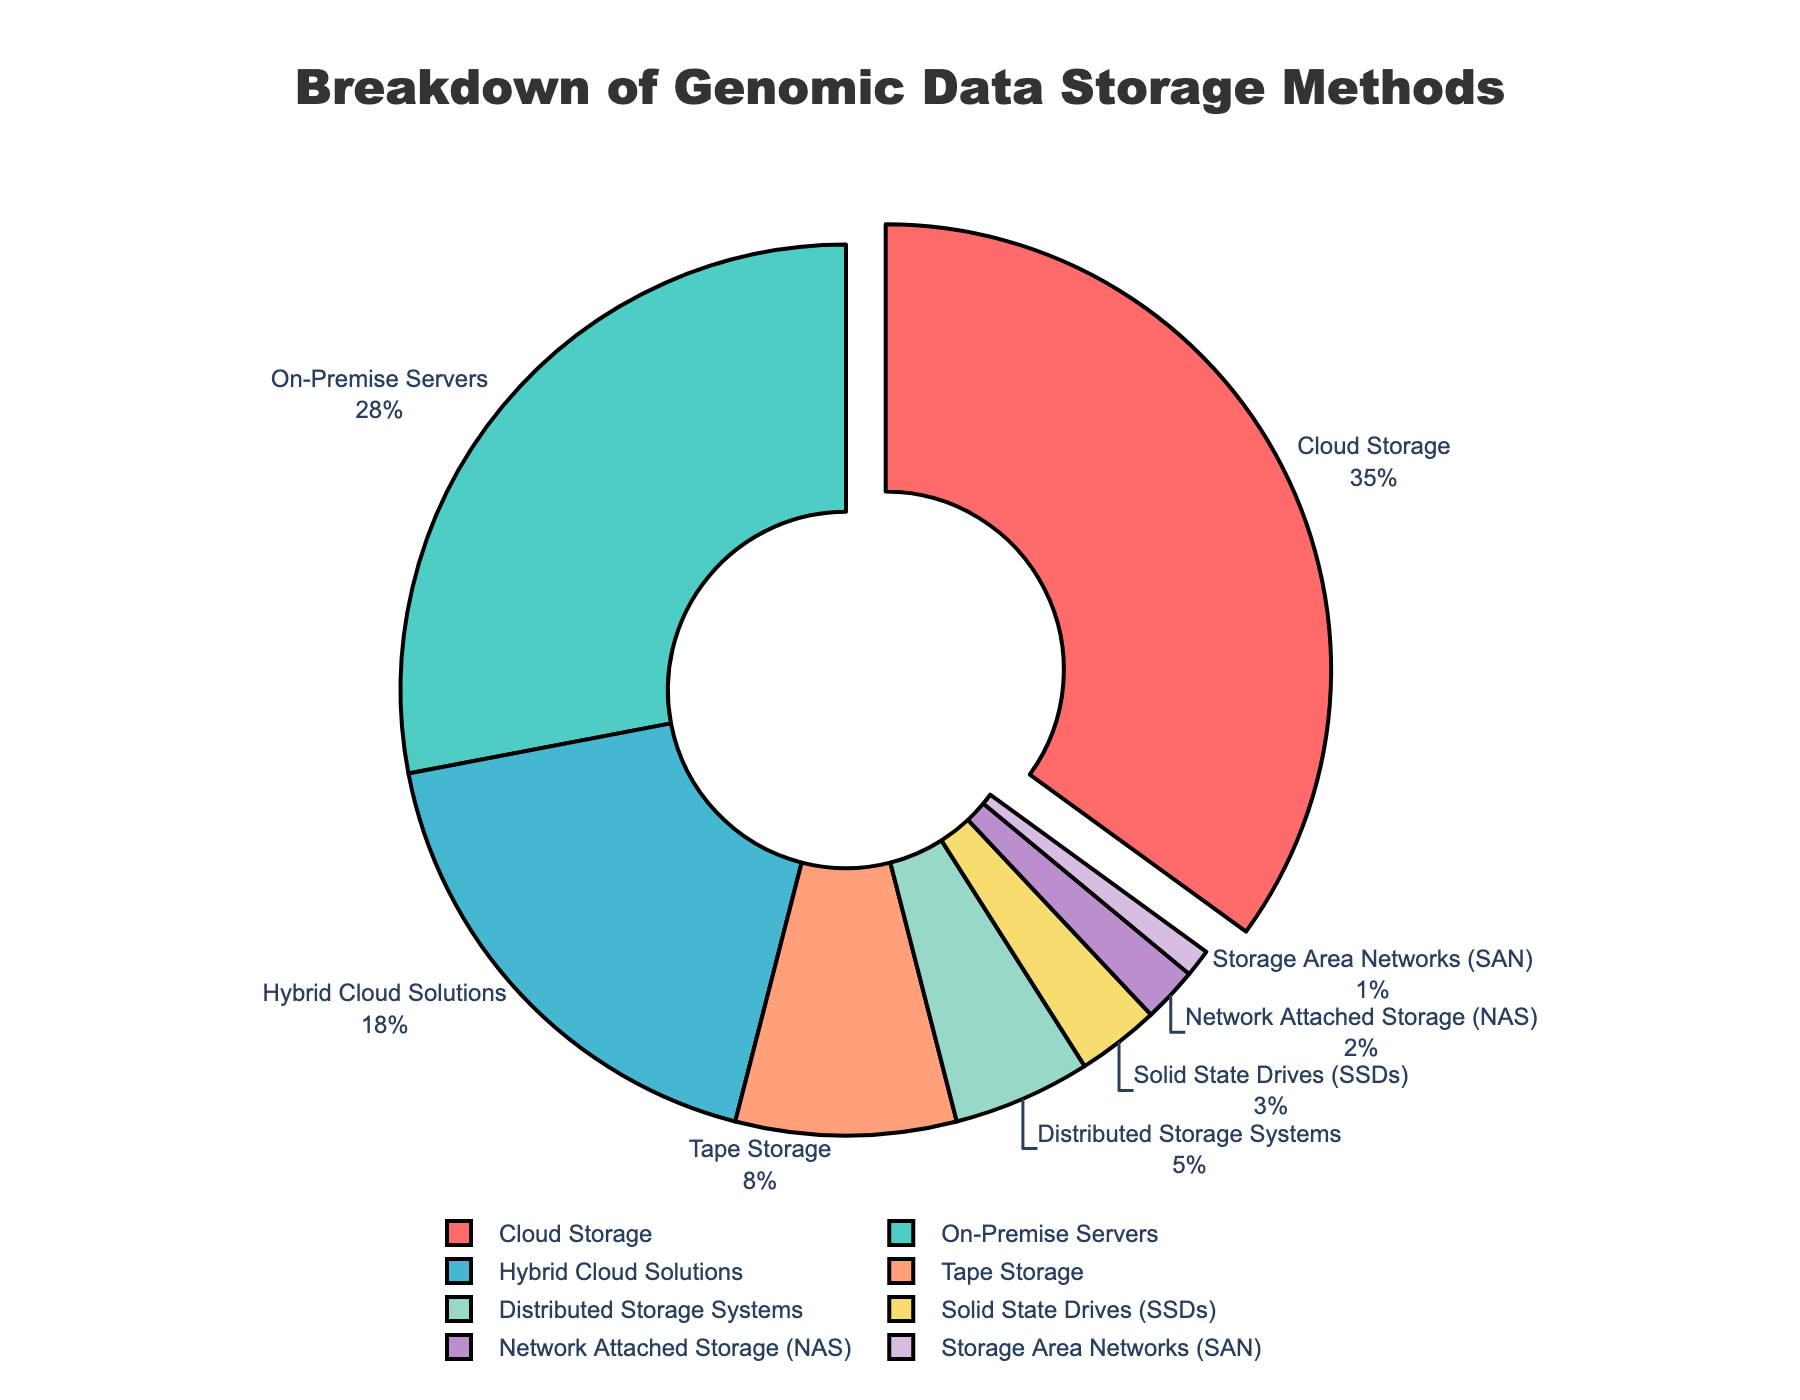What's the largest slice in the pie chart? The largest slice in the pie chart represents the category with the highest percentage of usage. By looking at the chart, the slice for Cloud Storage stands out as the largest.
Answer: Cloud Storage How much more percentage does Cloud Storage hold compared to On-Premise Servers? Identify the percentages for both Cloud Storage (35%) and On-Premise Servers (28%). Subtract the percentage of On-Premise Servers from that of Cloud Storage (35% - 28%).
Answer: 7% Which storage method accounts for the smallest percentage? Look for the smallest slice in the pie chart. The slice labeled with the smallest percentage is for Storage Area Networks (SAN), which is 1%.
Answer: Storage Area Networks (SAN) What is the total percentage of methods that use cloud solutions (Cloud Storage and Hybrid Cloud Solutions)? Add the percentage of Cloud Storage (35%) to that of Hybrid Cloud Solutions (18%). The sum represents the total percentage of cloud solutions. (35% + 18%).
Answer: 53% How does the percentage of Hybrid Cloud Solutions compare to that of Tape Storage? Identify the percentages for both Hybrid Cloud Solutions (18%) and Tape Storage (8%). Compare by subtracting the smaller percentage from the larger one (18% - 8%).
Answer: 10% What is the combined percentage of Solid State Drives (SSDs), Network Attached Storage (NAS), and Storage Area Networks (SAN)? Add the percentages for SSDs (3%), NAS (2%), and SAN (1%). The resulting sum is the combined percentage (3% + 2% + 1%).
Answer: 6% Which storage category is represented by a green slice? By observing the colors of the slices, the green slice corresponds to On-Premise Servers.
Answer: On-Premise Servers What is the difference in percentage between the largest storage category and the combined percentage of Tape Storage and Distributed Storage Systems? First, identify the largest storage category, which is Cloud Storage (35%). Then, find the sum of Tape Storage (8%) and Distributed Storage Systems (5%) which is (8% + 5% = 13%). Subtract this sum from the percentage of Cloud Storage (35% - 13%).
Answer: 22% Which two categories together almost occupy half of the chart? Identify the two largest slices: Cloud Storage (35%) and On-Premise Servers (28%). Sum their percentages (35% + 28%). The combined percentage is close to 50%.
Answer: Cloud Storage and On-Premise Servers By how much does the percentage of Solid State Drives (SSDs) exceed that of Storage Area Networks (SAN)? Identify the percentages for Solid State Drives (3%) and Storage Area Networks (1%). Subtract the percentage of SAN from that of SSDs (3% - 1%).
Answer: 2% 